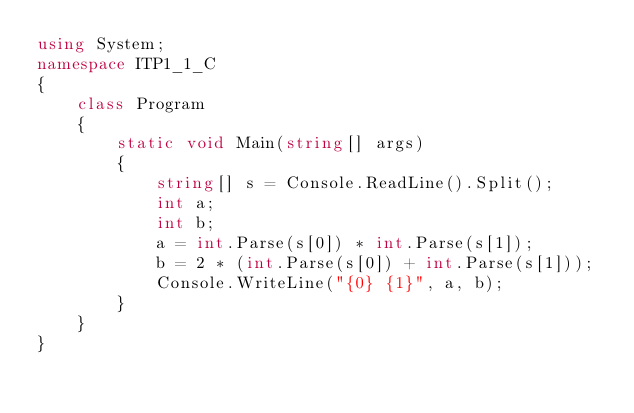<code> <loc_0><loc_0><loc_500><loc_500><_C#_>using System;
namespace ITP1_1_C
{
    class Program
    {
        static void Main(string[] args)
        {
            string[] s = Console.ReadLine().Split();
            int a;
            int b;
            a = int.Parse(s[0]) * int.Parse(s[1]);
            b = 2 * (int.Parse(s[0]) + int.Parse(s[1]));
            Console.WriteLine("{0} {1}", a, b);
        }
    }
}
</code> 